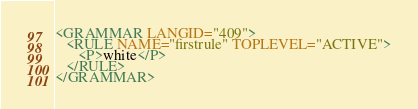Convert code to text. <code><loc_0><loc_0><loc_500><loc_500><_XML_><GRAMMAR LANGID="409">
   <RULE NAME="firstrule" TOPLEVEL="ACTIVE">
      <P>white</P> 
   </RULE>
</GRAMMAR>
</code> 